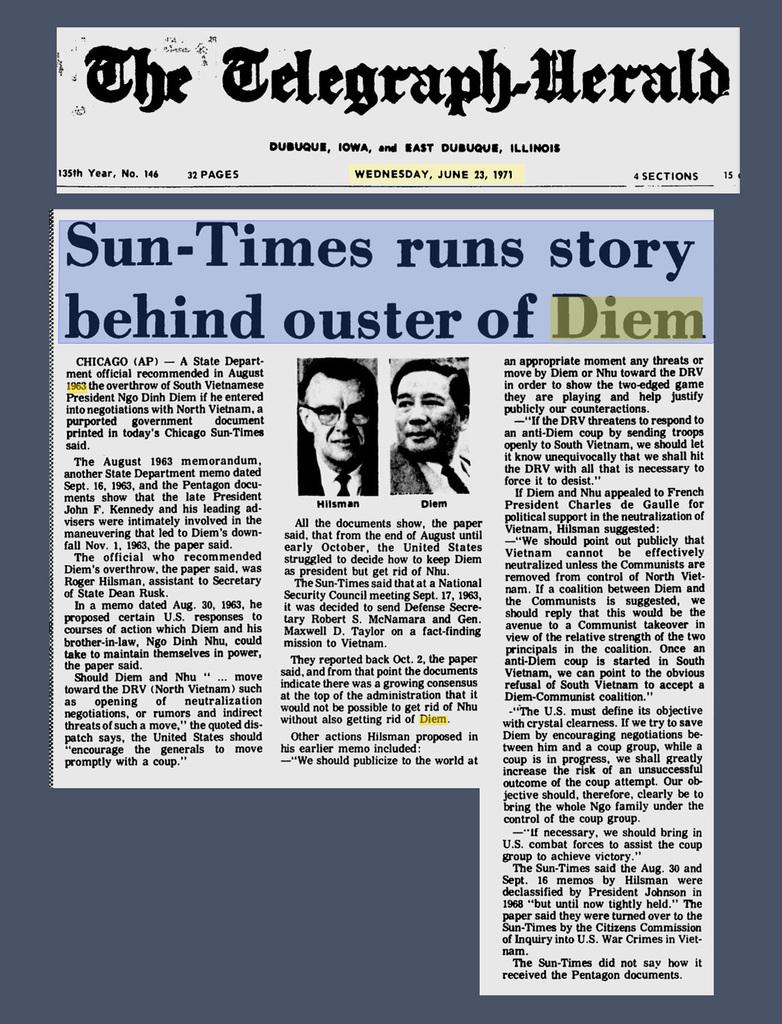What is present on the paper in the image? The paper contains text. Can you describe the people in the image? There are two men in the image. What type of honey is being used to write the text on the paper? There is no honey present in the image, and the text is not written with honey. 